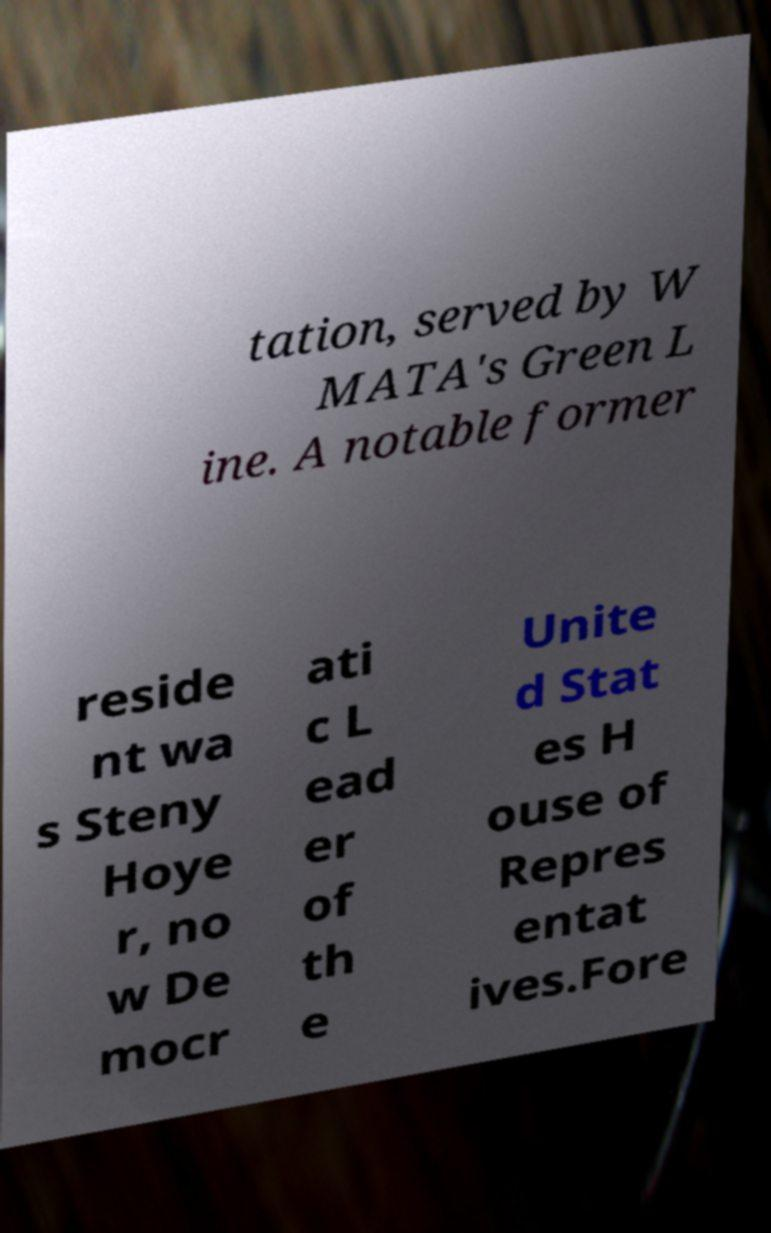There's text embedded in this image that I need extracted. Can you transcribe it verbatim? tation, served by W MATA's Green L ine. A notable former reside nt wa s Steny Hoye r, no w De mocr ati c L ead er of th e Unite d Stat es H ouse of Repres entat ives.Fore 